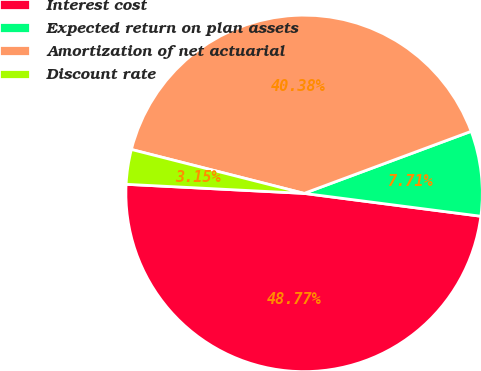<chart> <loc_0><loc_0><loc_500><loc_500><pie_chart><fcel>Interest cost<fcel>Expected return on plan assets<fcel>Amortization of net actuarial<fcel>Discount rate<nl><fcel>48.77%<fcel>7.71%<fcel>40.38%<fcel>3.15%<nl></chart> 